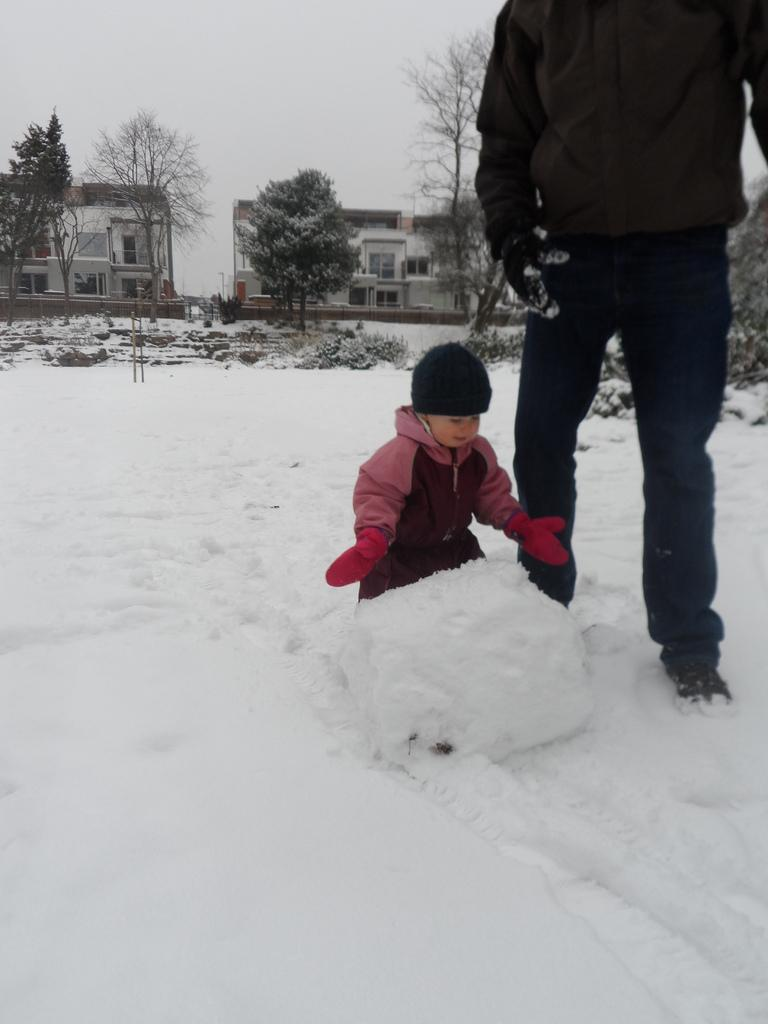Who is present in the image? There is a person and a child in the image. What is the setting of the image? Both the person and the child are standing on the snow. What can be seen in the background of the image? There are buildings, trees, poles, and the sky visible in the background of the image. What type of fruit is the child holding in the image? There is no fruit present in the image; the child is standing on the snow with the person. 